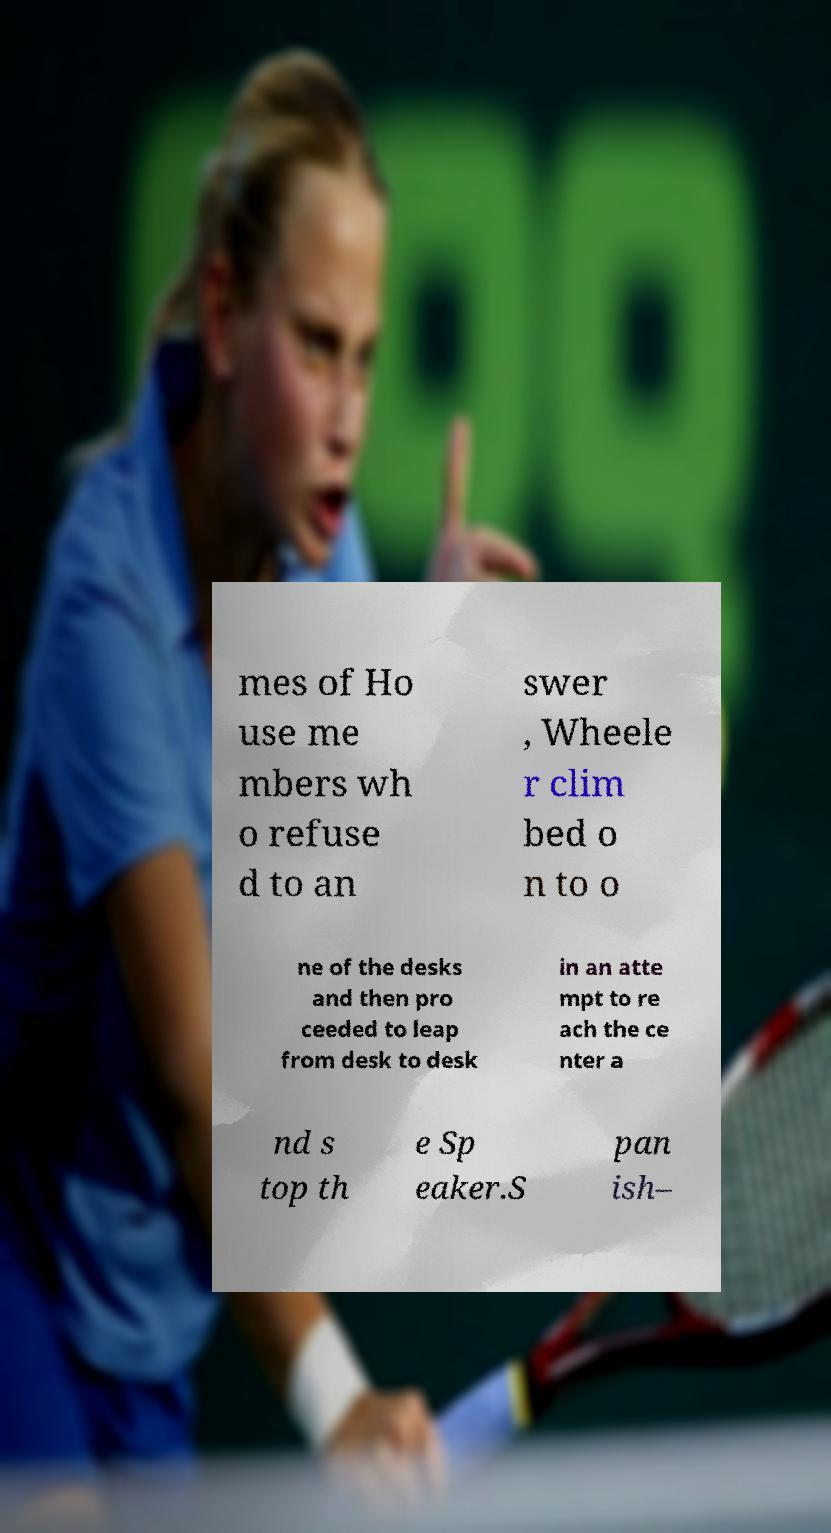Could you assist in decoding the text presented in this image and type it out clearly? mes of Ho use me mbers wh o refuse d to an swer , Wheele r clim bed o n to o ne of the desks and then pro ceeded to leap from desk to desk in an atte mpt to re ach the ce nter a nd s top th e Sp eaker.S pan ish– 